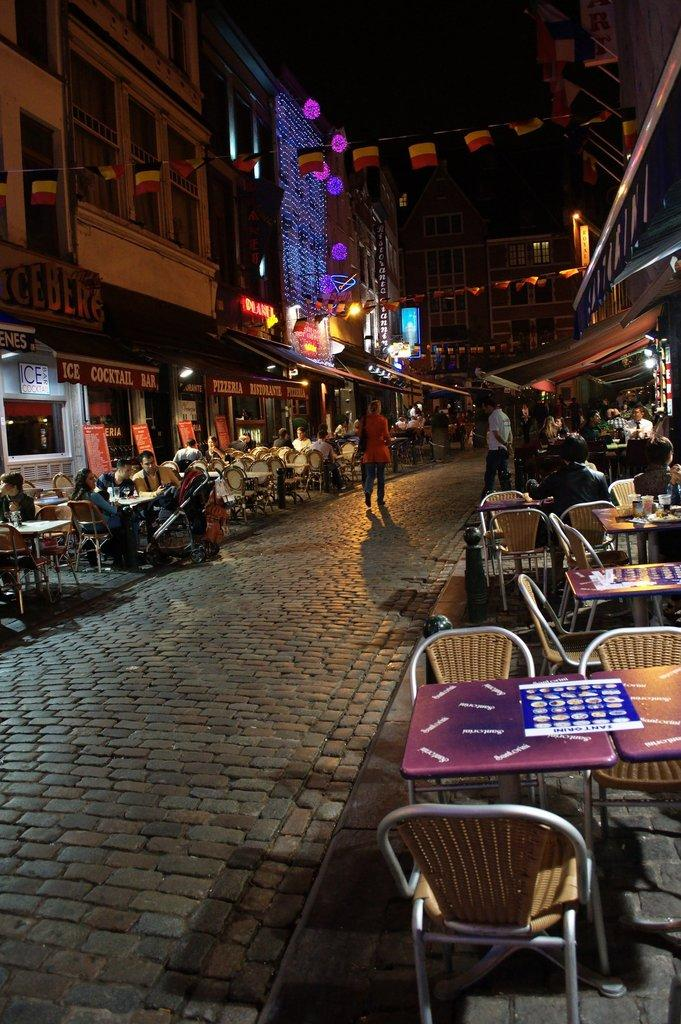What type of furniture is present in the image? There are chairs and tables in the image. What are the people doing in relation to the chairs? People are sitting on chairs in the image. Where are the people standing in the image? There are people standing on a road in the image. What type of structures can be seen in the image? Buildings are visible in the image. What type of crook can be seen in the image? There is no crook present in the image. What type of harmony is being displayed by the people in the image? The image does not depict any specific harmony among the people; it simply shows them sitting on chairs and standing on a road. 